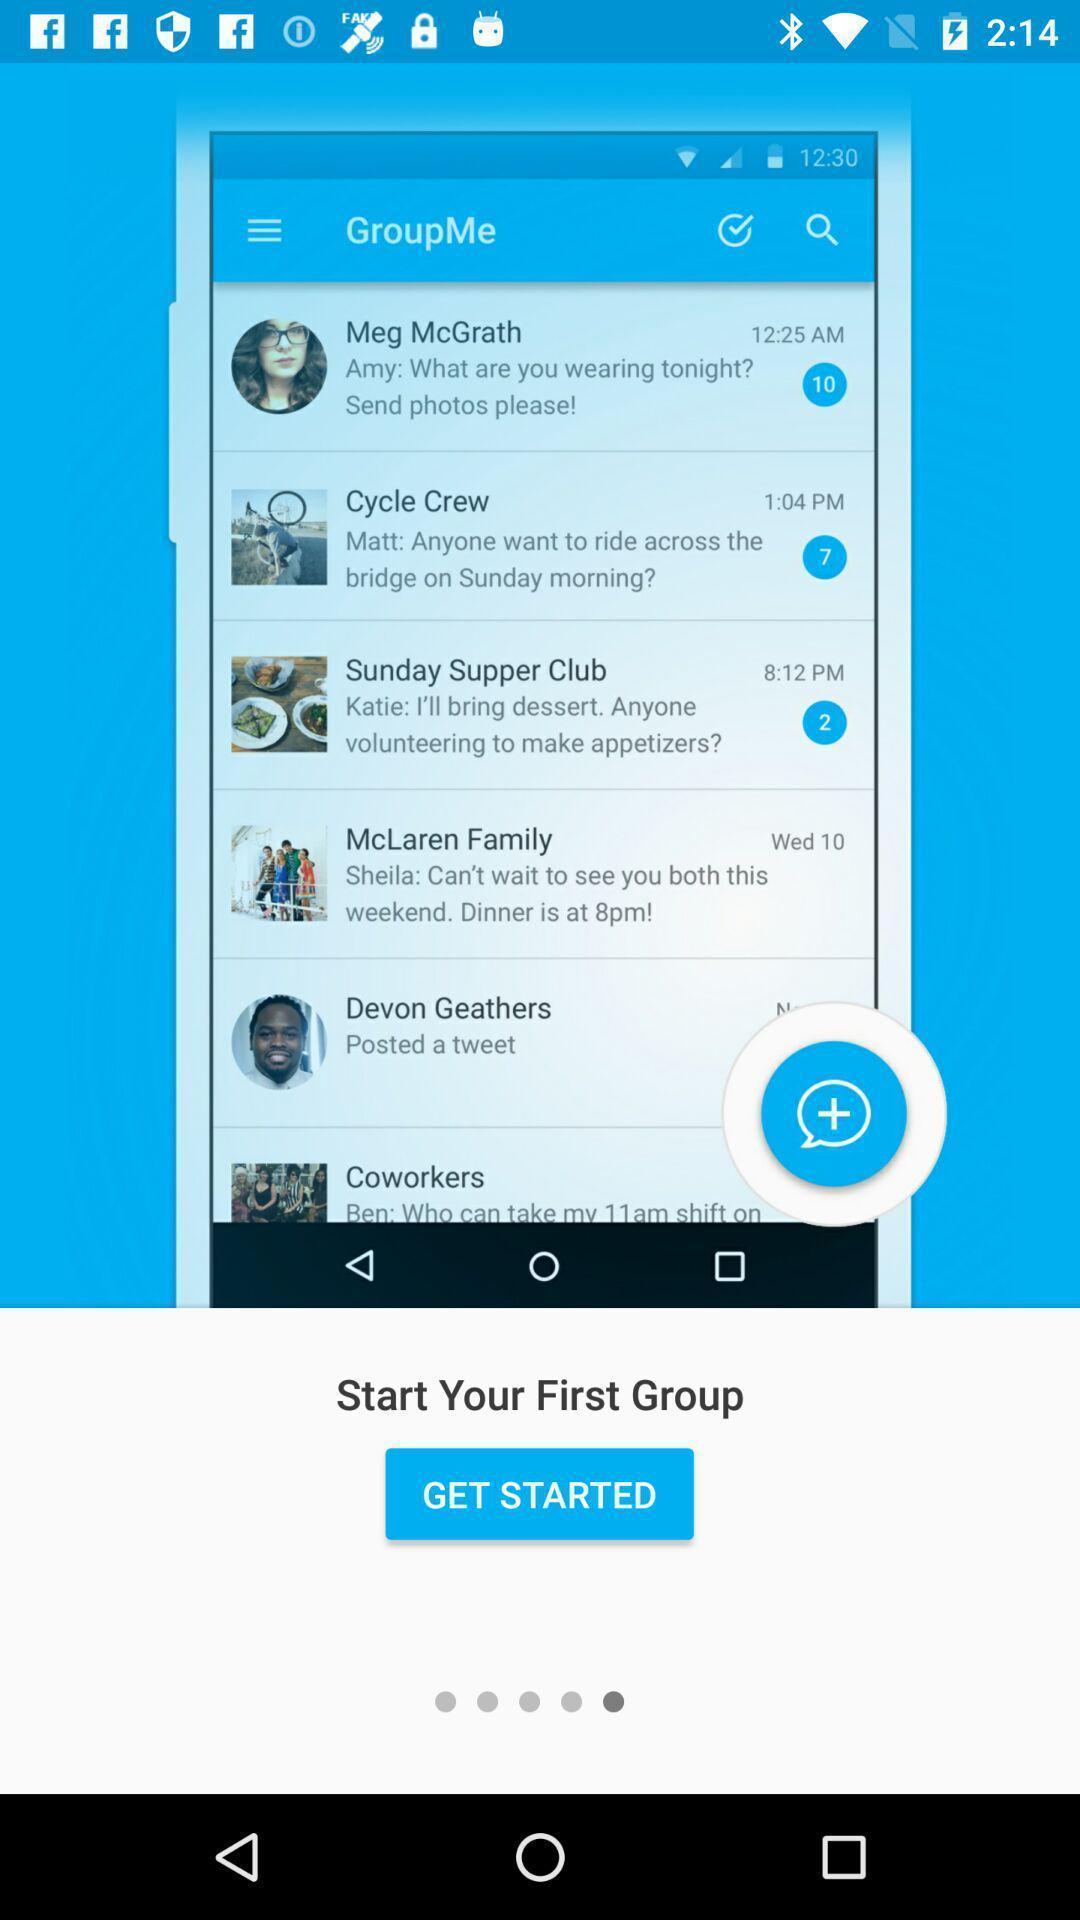Provide a textual representation of this image. Start page. 